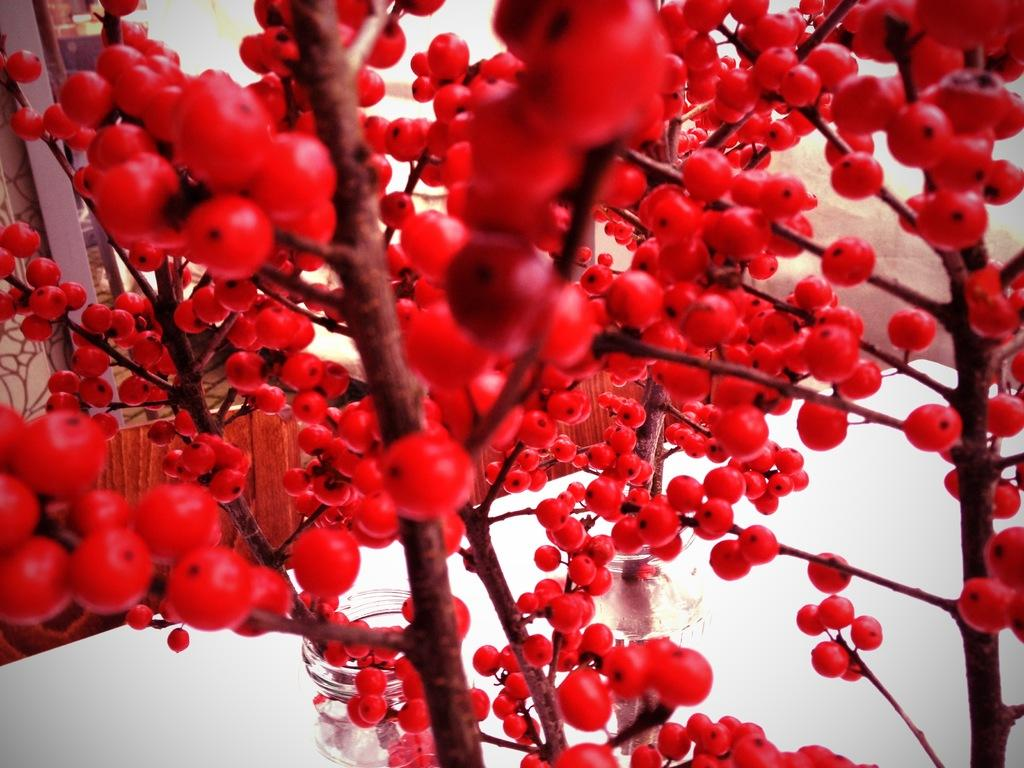What type of plant can be seen in the image? There is a tree in the image. What is unique about the fruits on the tree? The tree has red color fruits. What method is used to measure the air pressure in the image? There is no indication of any air pressure measurement in the image; it simply features a tree with red fruits. What type of pipe can be seen connected to the tree in the image? There is no pipe present in the image; it only shows a tree with red fruits. 